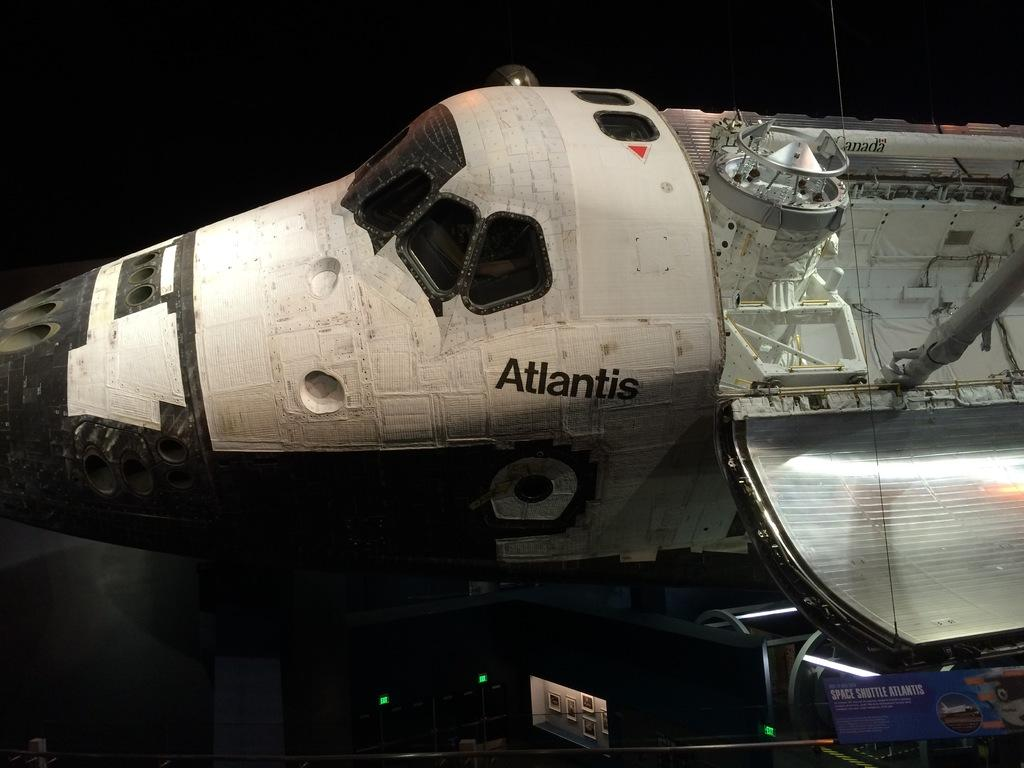What is the main subject in the middle of the image? There is an aircraft in the middle of the image. What can be seen at the bottom of the image? There are posters and lights at the bottom of the image. Is there any text present in the image? Yes, there is text at the bottom of the image. How many tomatoes are hanging from the aircraft in the image? There are no tomatoes present in the image, and therefore no such activity can be observed. 